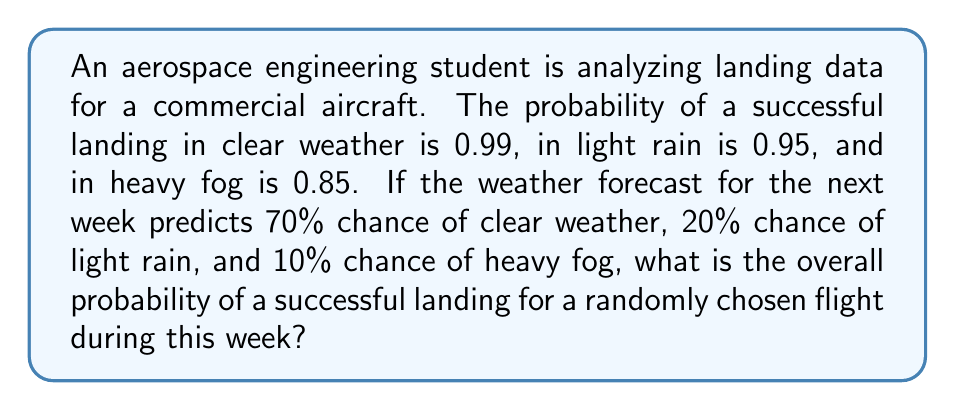Give your solution to this math problem. Let's approach this step-by-step using the law of total probability:

1) Define events:
   S: Successful landing
   C: Clear weather
   R: Light rain
   F: Heavy fog

2) Given probabilities:
   P(S|C) = 0.99 (probability of success given clear weather)
   P(S|R) = 0.95 (probability of success given light rain)
   P(S|F) = 0.85 (probability of success given heavy fog)
   P(C) = 0.70 (probability of clear weather)
   P(R) = 0.20 (probability of light rain)
   P(F) = 0.10 (probability of heavy fog)

3) Law of Total Probability:
   $$P(S) = P(S|C)P(C) + P(S|R)P(R) + P(S|F)P(F)$$

4) Substitute the values:
   $$P(S) = (0.99)(0.70) + (0.95)(0.20) + (0.85)(0.10)$$

5) Calculate:
   $$P(S) = 0.693 + 0.190 + 0.085 = 0.968$$

Therefore, the overall probability of a successful landing is 0.968 or 96.8%.
Answer: 0.968 